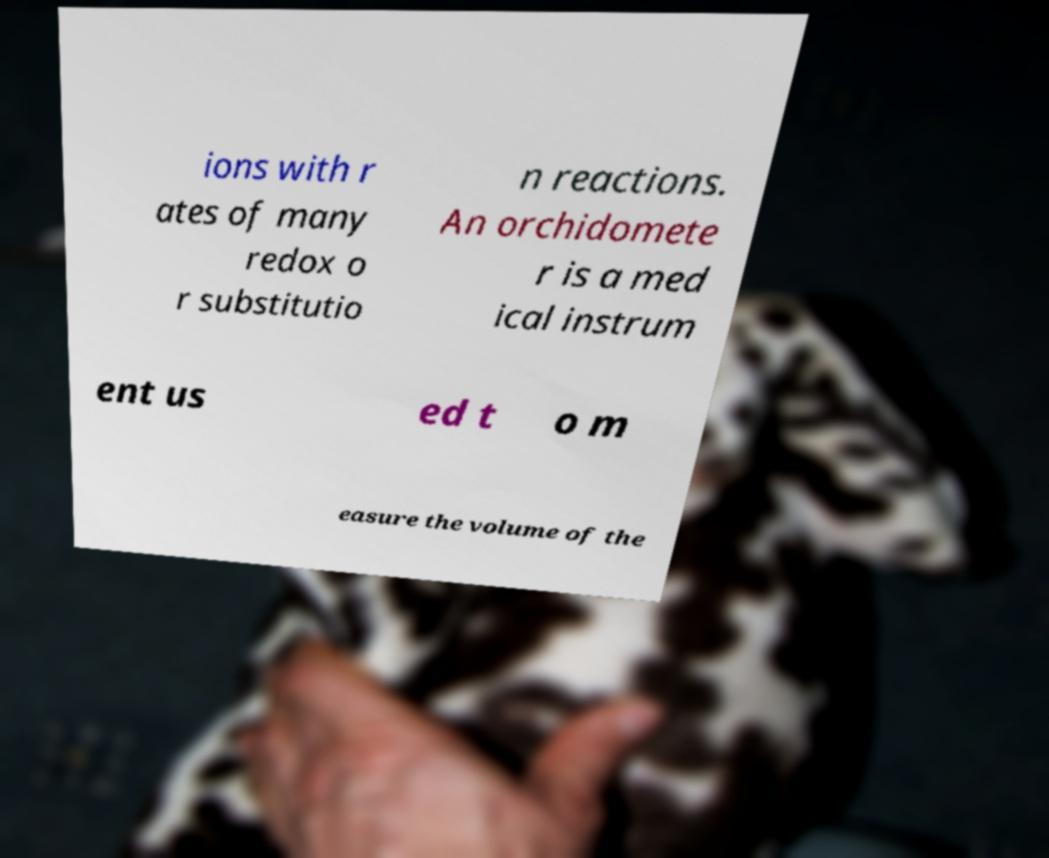Could you extract and type out the text from this image? ions with r ates of many redox o r substitutio n reactions. An orchidomete r is a med ical instrum ent us ed t o m easure the volume of the 